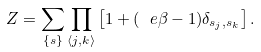<formula> <loc_0><loc_0><loc_500><loc_500>Z = \sum _ { \{ s \} } \prod _ { \langle j , k \rangle } \left [ 1 + ( \ e { \beta } - 1 ) \delta _ { s _ { j } , s _ { k } } \right ] .</formula> 